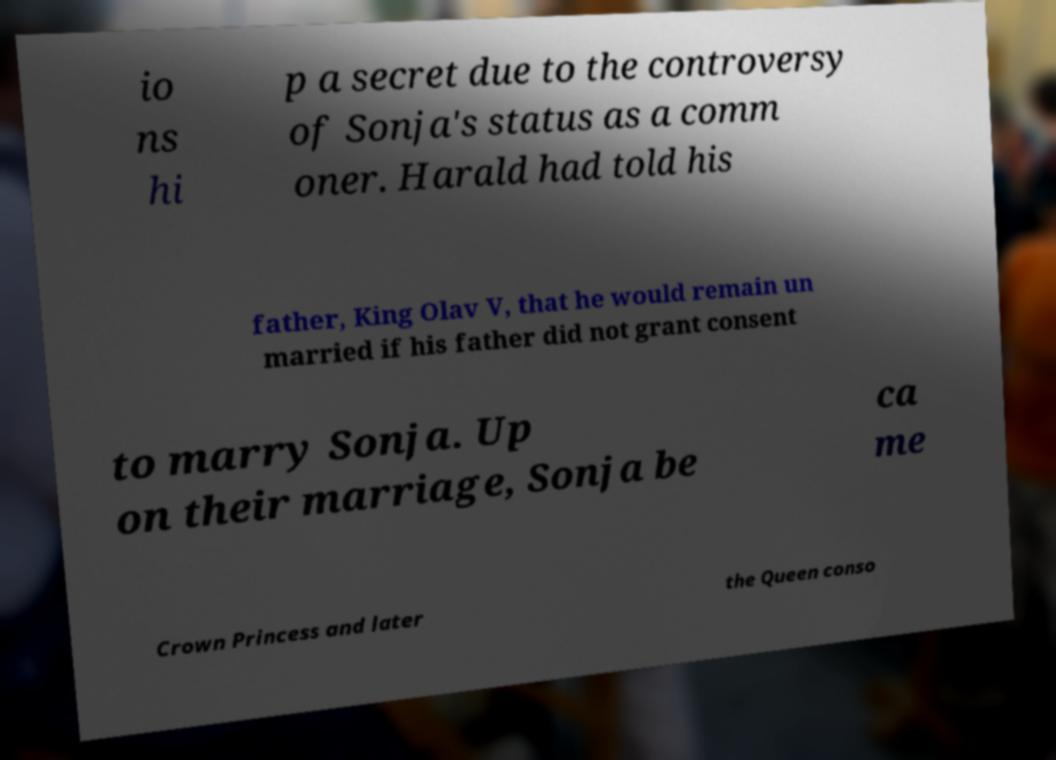For documentation purposes, I need the text within this image transcribed. Could you provide that? io ns hi p a secret due to the controversy of Sonja's status as a comm oner. Harald had told his father, King Olav V, that he would remain un married if his father did not grant consent to marry Sonja. Up on their marriage, Sonja be ca me Crown Princess and later the Queen conso 